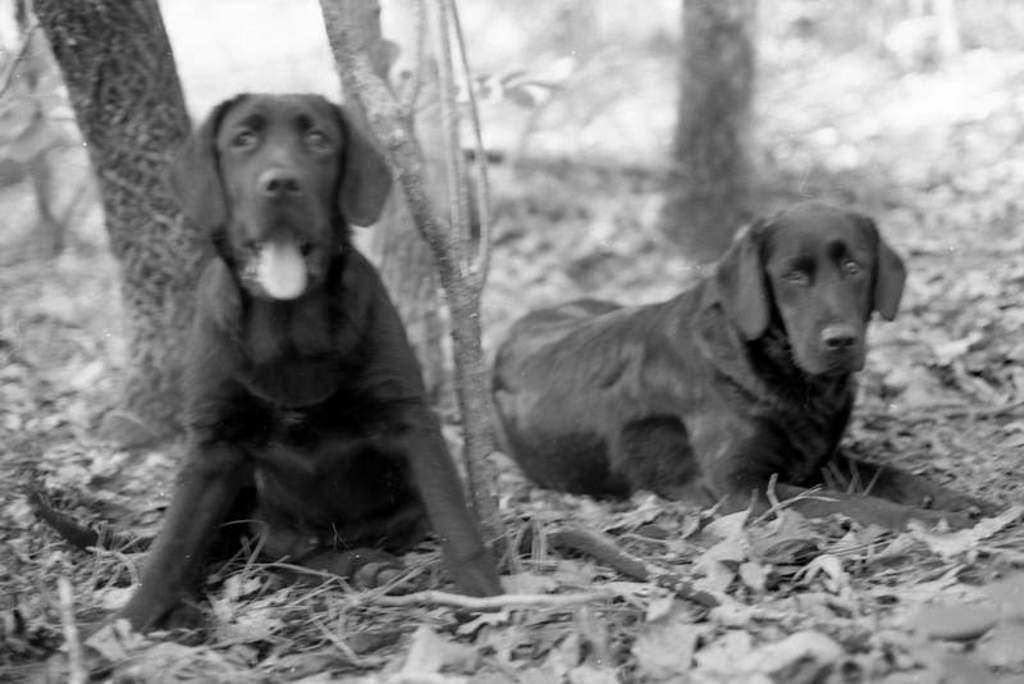In one or two sentences, can you explain what this image depicts? In this picture I can see animals on the surface. 